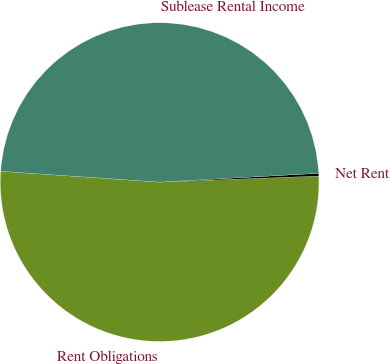Convert chart to OTSL. <chart><loc_0><loc_0><loc_500><loc_500><pie_chart><fcel>Rent Obligations<fcel>Net Rent<fcel>Sublease Rental Income<nl><fcel>51.69%<fcel>0.27%<fcel>48.04%<nl></chart> 